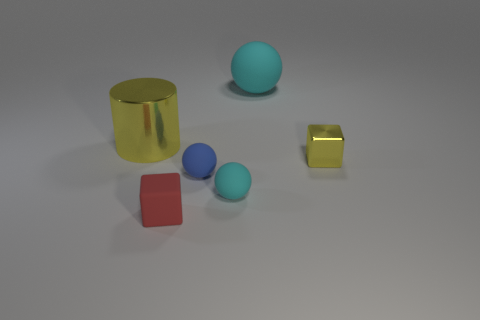Subtract all cyan rubber spheres. How many spheres are left? 1 Add 2 large brown shiny objects. How many objects exist? 8 Subtract all blue spheres. How many spheres are left? 2 Subtract all blocks. How many objects are left? 4 Subtract 1 blocks. How many blocks are left? 1 Add 5 cyan things. How many cyan things are left? 7 Add 5 small yellow metallic blocks. How many small yellow metallic blocks exist? 6 Subtract 1 red cubes. How many objects are left? 5 Subtract all blue cylinders. Subtract all green blocks. How many cylinders are left? 1 Subtract all gray balls. How many red cubes are left? 1 